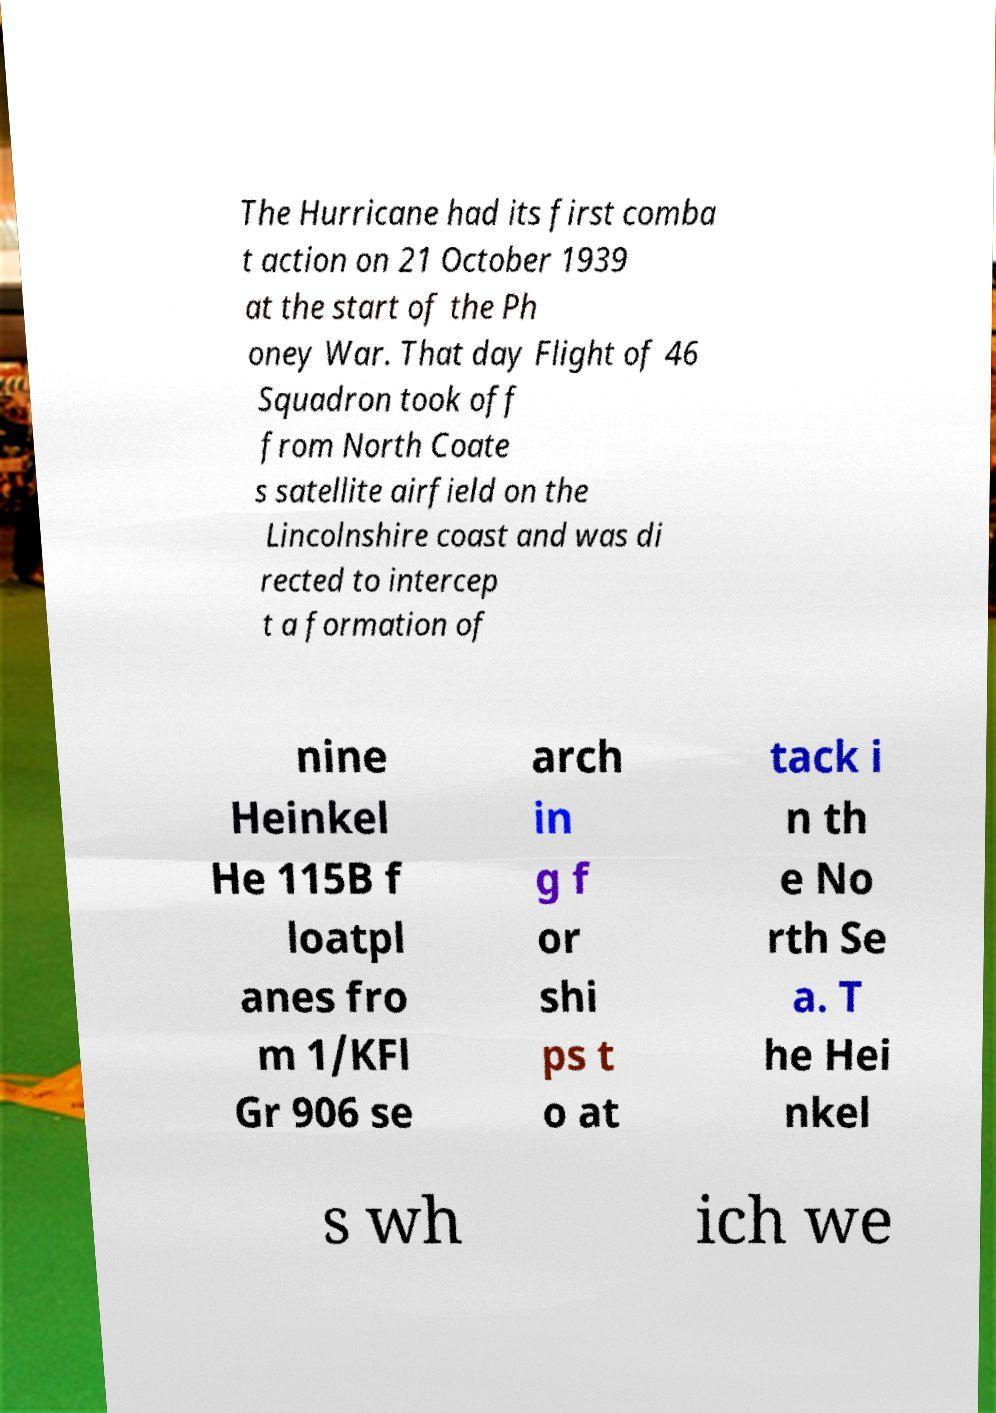Could you assist in decoding the text presented in this image and type it out clearly? The Hurricane had its first comba t action on 21 October 1939 at the start of the Ph oney War. That day Flight of 46 Squadron took off from North Coate s satellite airfield on the Lincolnshire coast and was di rected to intercep t a formation of nine Heinkel He 115B f loatpl anes fro m 1/KFl Gr 906 se arch in g f or shi ps t o at tack i n th e No rth Se a. T he Hei nkel s wh ich we 